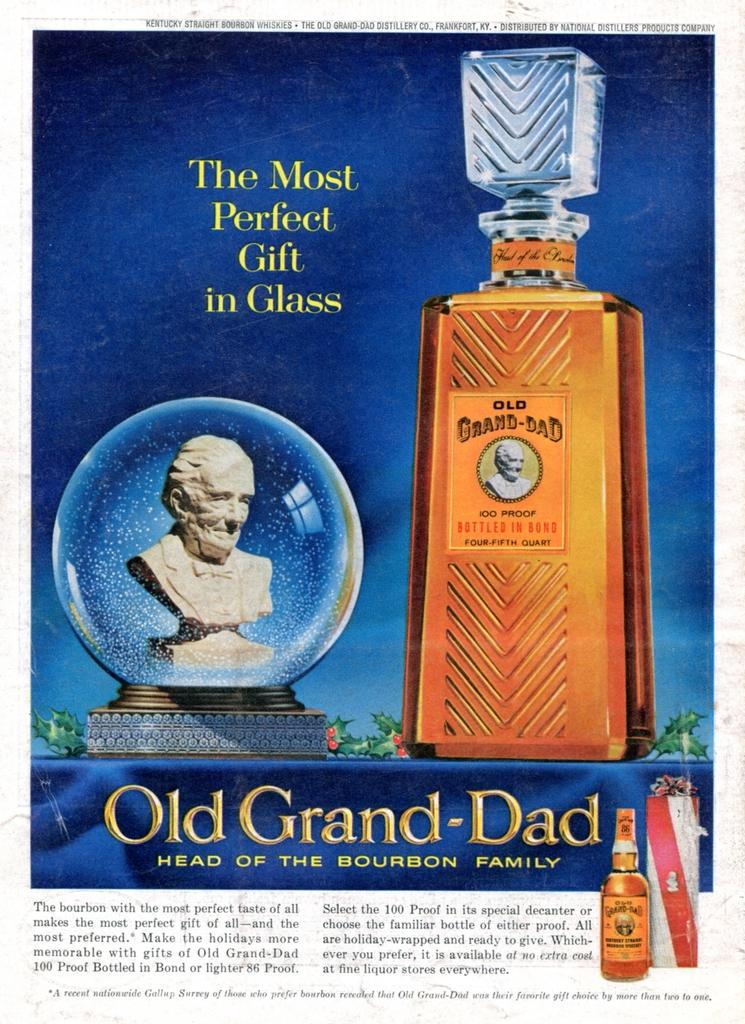Provide a one-sentence caption for the provided image. A magazine advertisement of a very fancy Bourbon and a head statue,. 